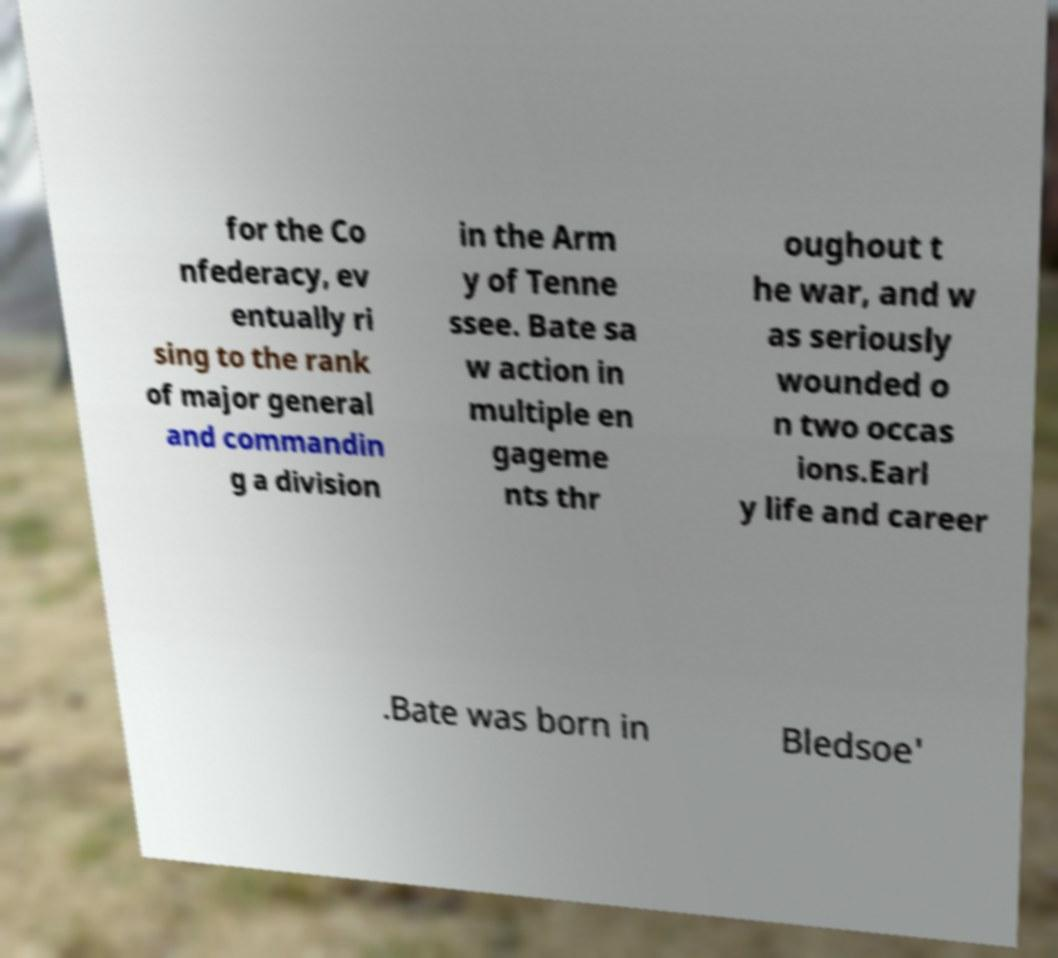Can you read and provide the text displayed in the image?This photo seems to have some interesting text. Can you extract and type it out for me? for the Co nfederacy, ev entually ri sing to the rank of major general and commandin g a division in the Arm y of Tenne ssee. Bate sa w action in multiple en gageme nts thr oughout t he war, and w as seriously wounded o n two occas ions.Earl y life and career .Bate was born in Bledsoe' 